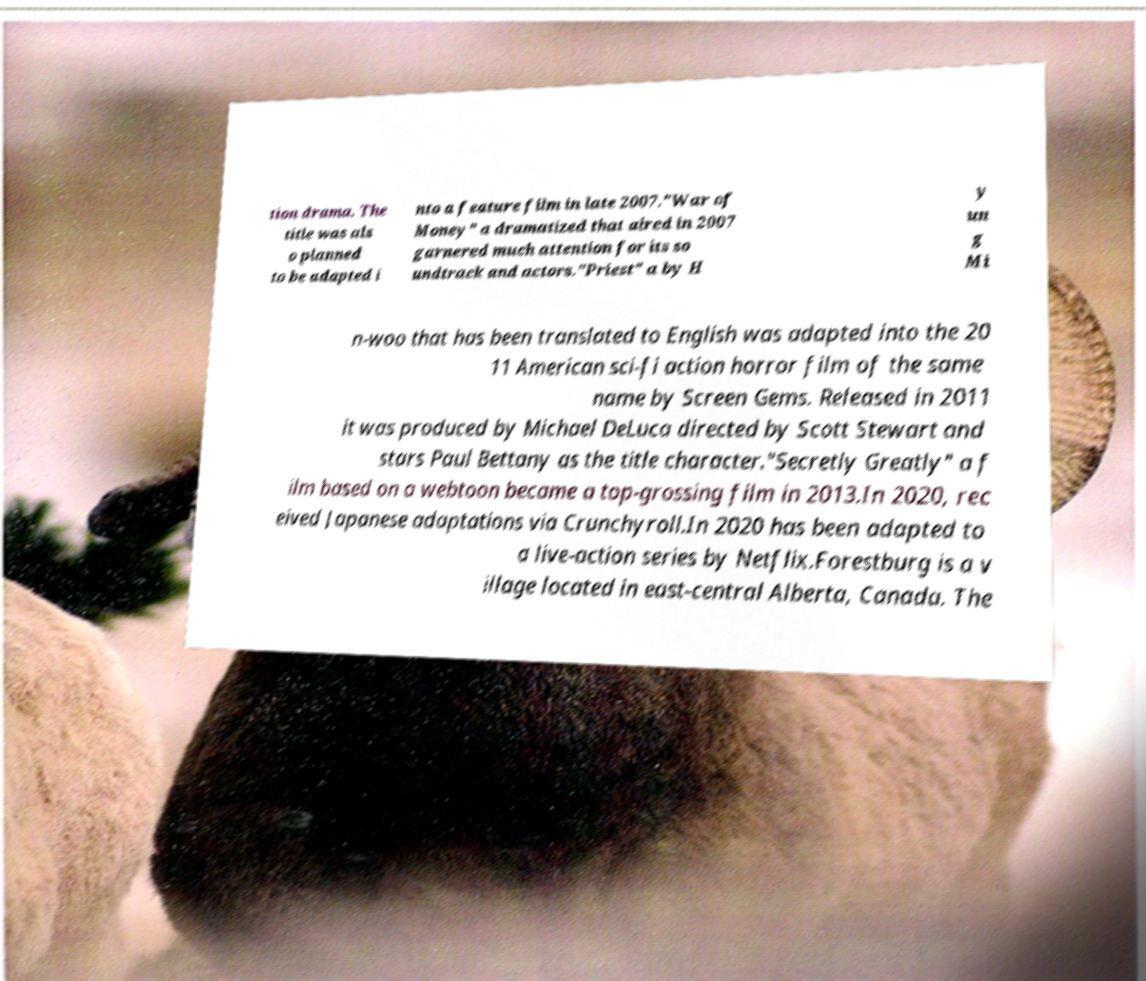There's text embedded in this image that I need extracted. Can you transcribe it verbatim? tion drama. The title was als o planned to be adapted i nto a feature film in late 2007."War of Money" a dramatized that aired in 2007 garnered much attention for its so undtrack and actors."Priest" a by H y un g Mi n-woo that has been translated to English was adapted into the 20 11 American sci-fi action horror film of the same name by Screen Gems. Released in 2011 it was produced by Michael DeLuca directed by Scott Stewart and stars Paul Bettany as the title character."Secretly Greatly" a f ilm based on a webtoon became a top-grossing film in 2013.In 2020, rec eived Japanese adaptations via Crunchyroll.In 2020 has been adapted to a live-action series by Netflix.Forestburg is a v illage located in east-central Alberta, Canada. The 